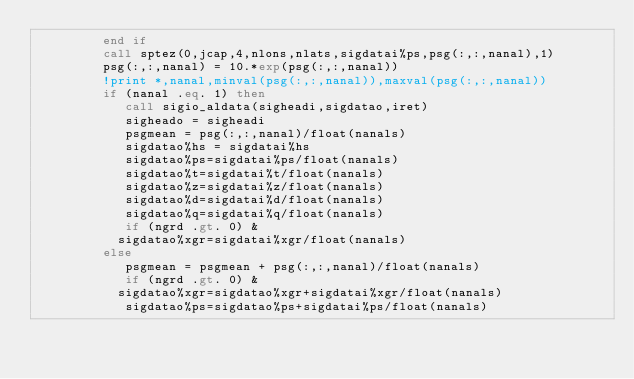Convert code to text. <code><loc_0><loc_0><loc_500><loc_500><_FORTRAN_>         end if
         call sptez(0,jcap,4,nlons,nlats,sigdatai%ps,psg(:,:,nanal),1)
         psg(:,:,nanal) = 10.*exp(psg(:,:,nanal))
         !print *,nanal,minval(psg(:,:,nanal)),maxval(psg(:,:,nanal))
         if (nanal .eq. 1) then
            call sigio_aldata(sigheadi,sigdatao,iret)
            sigheado = sigheadi
            psgmean = psg(:,:,nanal)/float(nanals)
            sigdatao%hs = sigdatai%hs
            sigdatao%ps=sigdatai%ps/float(nanals)
            sigdatao%t=sigdatai%t/float(nanals)
            sigdatao%z=sigdatai%z/float(nanals)
            sigdatao%d=sigdatai%d/float(nanals)
            sigdatao%q=sigdatai%q/float(nanals)
            if (ngrd .gt. 0) &
           sigdatao%xgr=sigdatai%xgr/float(nanals)
         else
            psgmean = psgmean + psg(:,:,nanal)/float(nanals)
            if (ngrd .gt. 0) &
           sigdatao%xgr=sigdatao%xgr+sigdatai%xgr/float(nanals)
            sigdatao%ps=sigdatao%ps+sigdatai%ps/float(nanals)</code> 